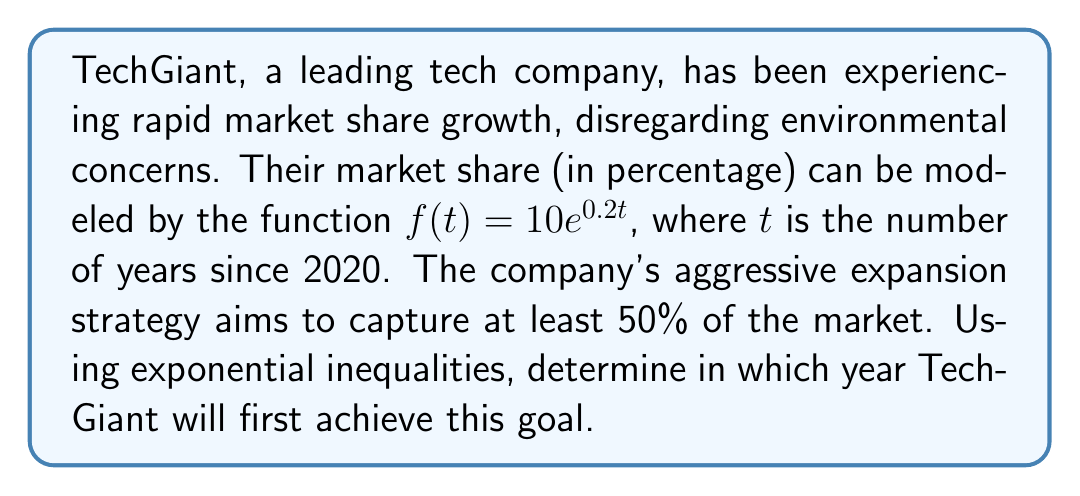Help me with this question. To solve this problem, we need to use exponential inequalities:

1) We want to find when the market share will be at least 50%:
   
   $f(t) \geq 50$

2) Substitute the given function:
   
   $10e^{0.2t} \geq 50$

3) Divide both sides by 10:
   
   $e^{0.2t} \geq 5$

4) Take the natural logarithm of both sides:
   
   $\ln(e^{0.2t}) \geq \ln(5)$
   
   $0.2t \geq \ln(5)$

5) Divide both sides by 0.2:
   
   $t \geq \frac{\ln(5)}{0.2} \approx 8.047$

6) Since $t$ represents years since 2020 and we need the first year this condition is met, we round up to the nearest whole number:
   
   $t = 9$

7) Add 9 to 2020 to get the actual year:
   
   $2020 + 9 = 2029$

Therefore, TechGiant will first achieve at least 50% market share in 2029.
Answer: 2029 